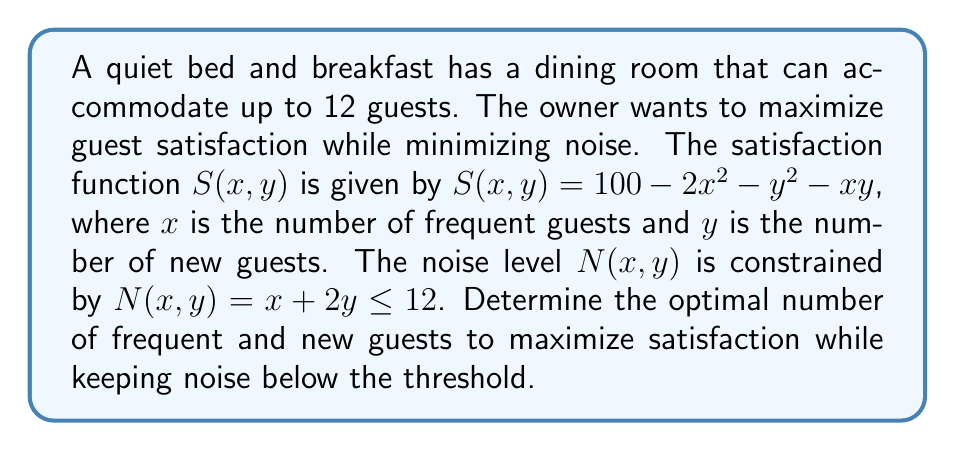Show me your answer to this math problem. 1. We need to maximize $S(x, y) = 100 - 2x^2 - y^2 - xy$ subject to the constraints:
   $x + 2y \leq 12$
   $x \geq 0$, $y \geq 0$

2. Use the method of Lagrange multipliers. Let $\lambda$ be the Lagrange multiplier:
   $L(x, y, \lambda) = 100 - 2x^2 - y^2 - xy + \lambda(12 - x - 2y)$

3. Find partial derivatives and set them to zero:
   $\frac{\partial L}{\partial x} = -4x - y - \lambda = 0$
   $\frac{\partial L}{\partial y} = -2y - x - 2\lambda = 0$
   $\frac{\partial L}{\partial \lambda} = 12 - x - 2y = 0$

4. From the third equation: $x = 12 - 2y$

5. Substitute into the first equation:
   $-4(12 - 2y) - y - \lambda = 0$
   $-48 + 8y - y - \lambda = 0$
   $7y - \lambda = 48$

6. From the second equation:
   $-2y - (12 - 2y) - 2\lambda = 0$
   $-2y - 12 + 2y - 2\lambda = 0$
   $-12 - 2\lambda = 0$
   $\lambda = -6$

7. Substitute $\lambda = -6$ into the equation from step 5:
   $7y - (-6) = 48$
   $7y = 42$
   $y = 6$

8. Calculate $x$ using the equation from step 4:
   $x = 12 - 2(6) = 0$

9. Check if this solution satisfies the constraints:
   $x + 2y = 0 + 2(6) = 12 \leq 12$
   $x = 0 \geq 0$, $y = 6 \geq 0$

10. Therefore, the optimal solution is $x = 0$ (frequent guests) and $y = 6$ (new guests).
Answer: $x = 0$, $y = 6$ 